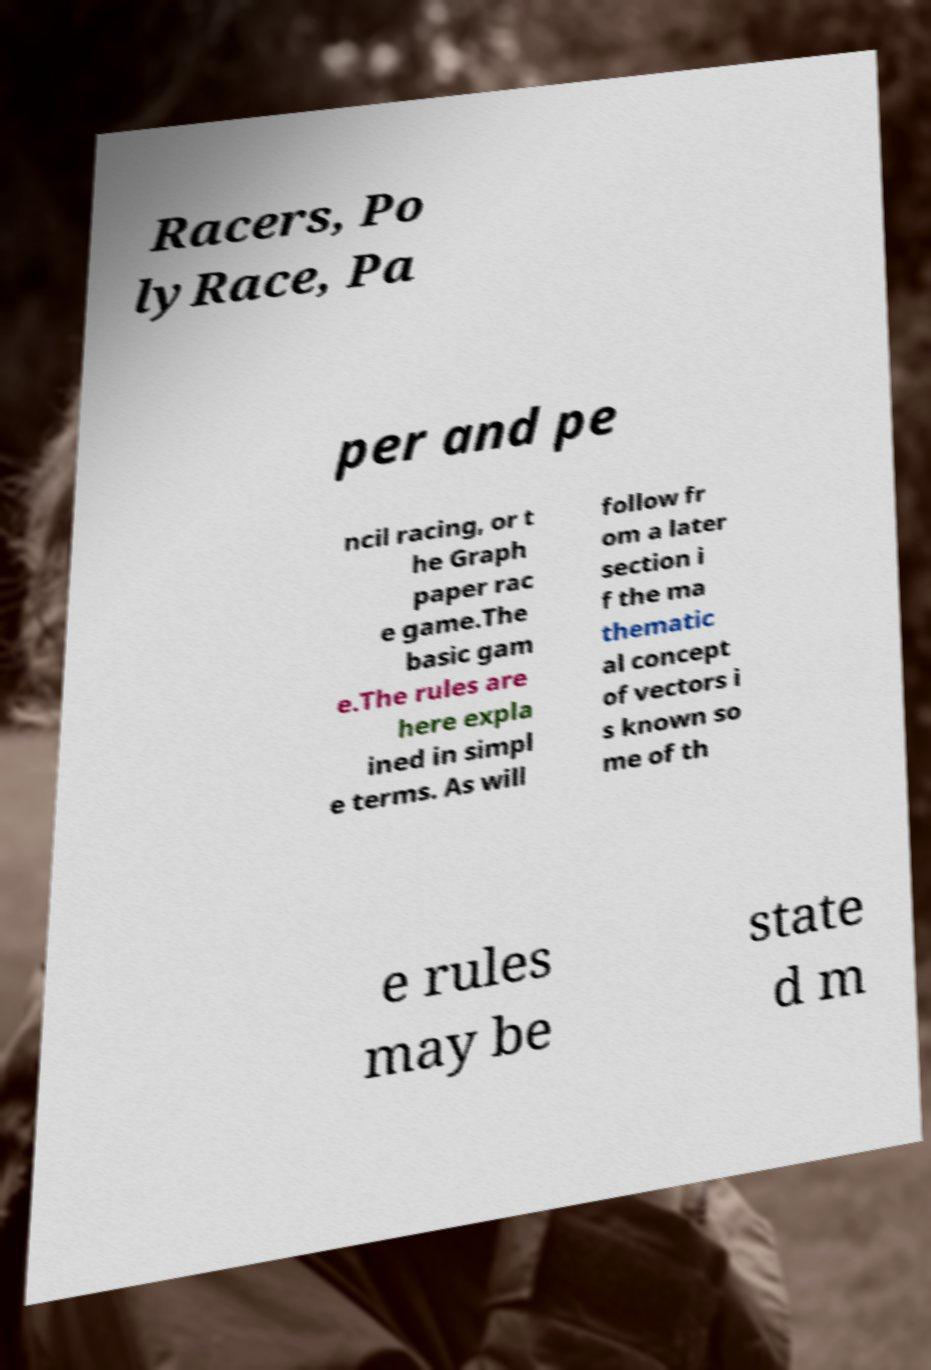I need the written content from this picture converted into text. Can you do that? Racers, Po lyRace, Pa per and pe ncil racing, or t he Graph paper rac e game.The basic gam e.The rules are here expla ined in simpl e terms. As will follow fr om a later section i f the ma thematic al concept of vectors i s known so me of th e rules may be state d m 